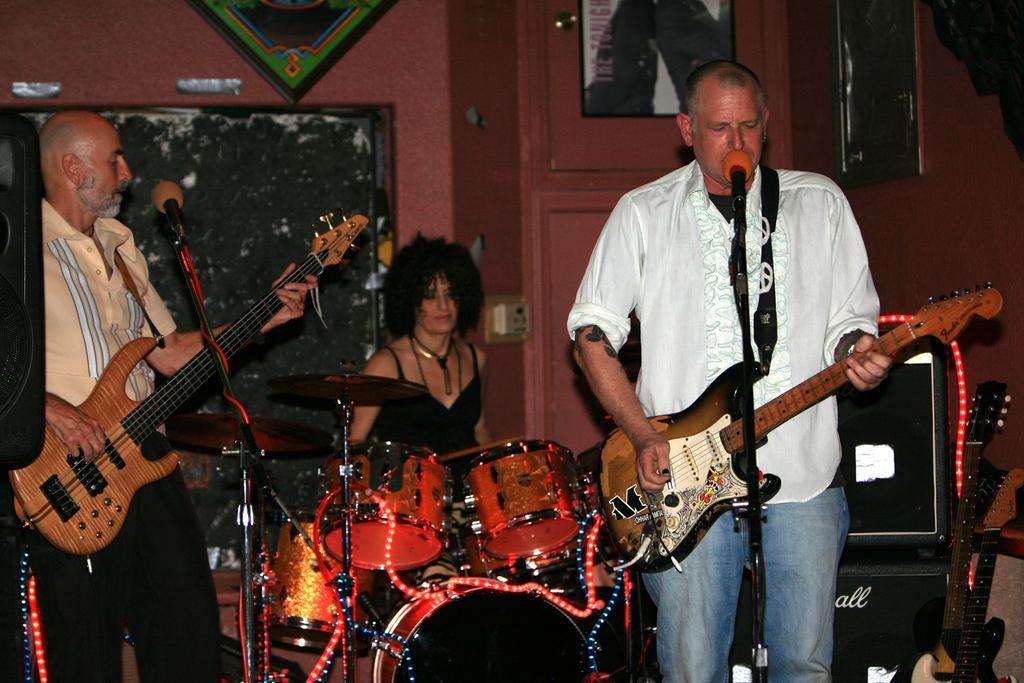Please provide a concise description of this image. In this image i can see 2 men standing and holding guitar in their hands, I can see microphones in front of them. In the background i can see a woman sitting in front of s musical system, the wall and few photo frames. 